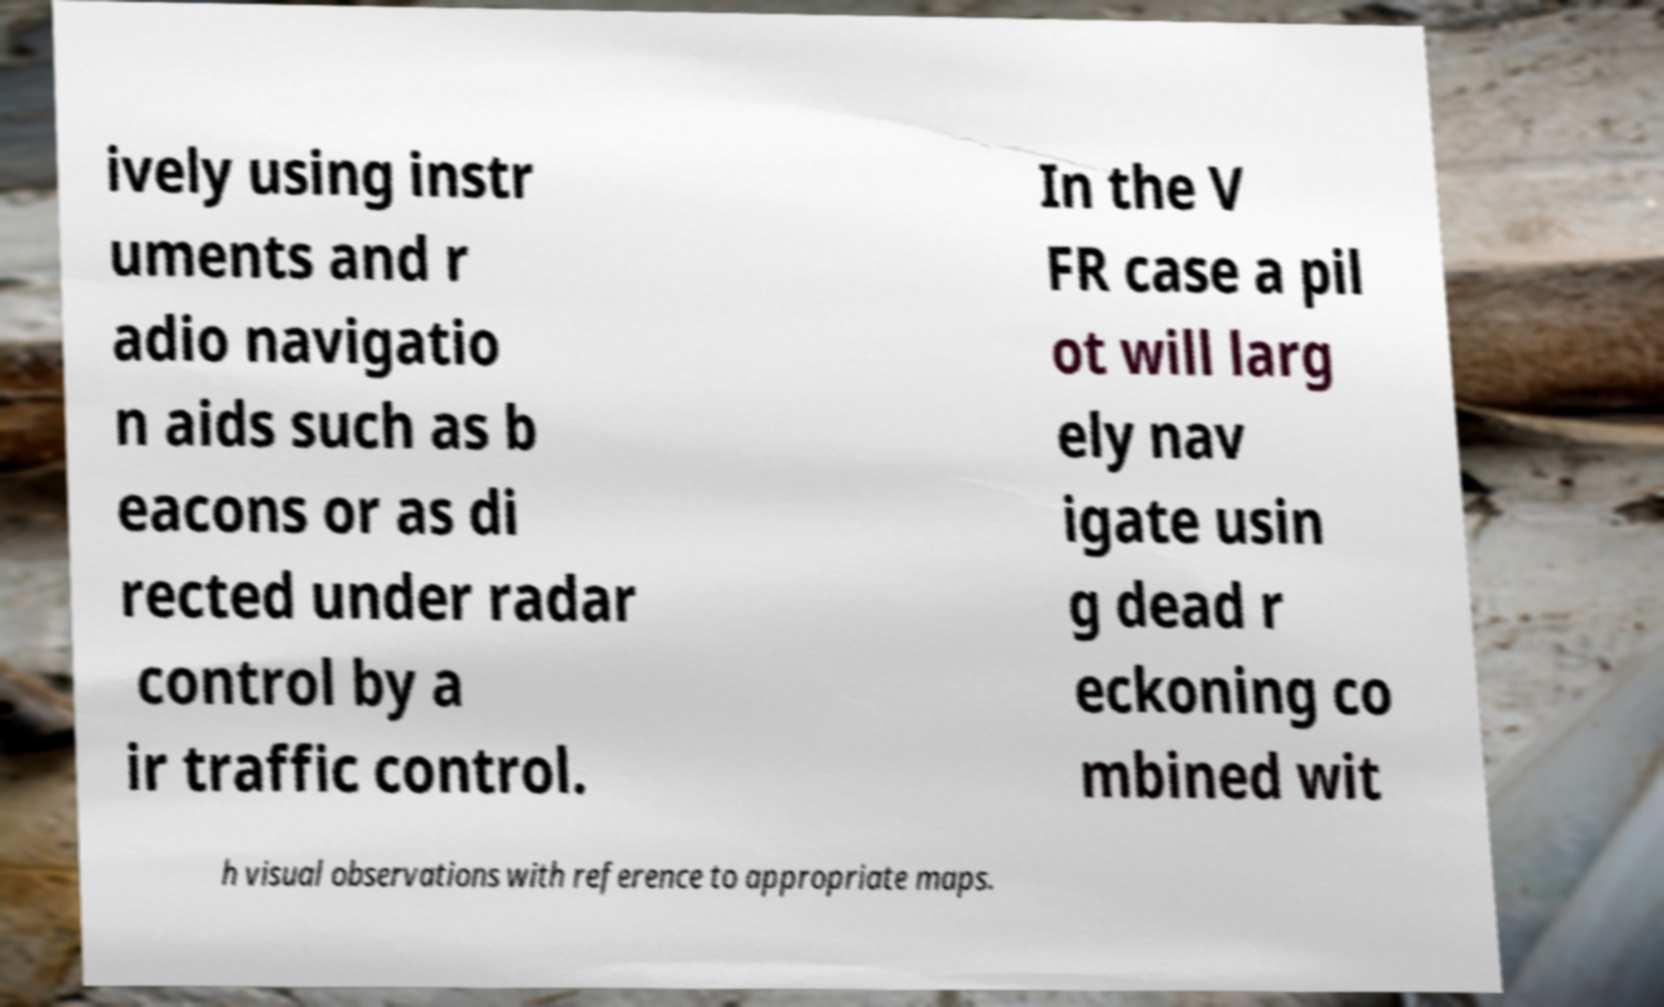Please identify and transcribe the text found in this image. ively using instr uments and r adio navigatio n aids such as b eacons or as di rected under radar control by a ir traffic control. In the V FR case a pil ot will larg ely nav igate usin g dead r eckoning co mbined wit h visual observations with reference to appropriate maps. 